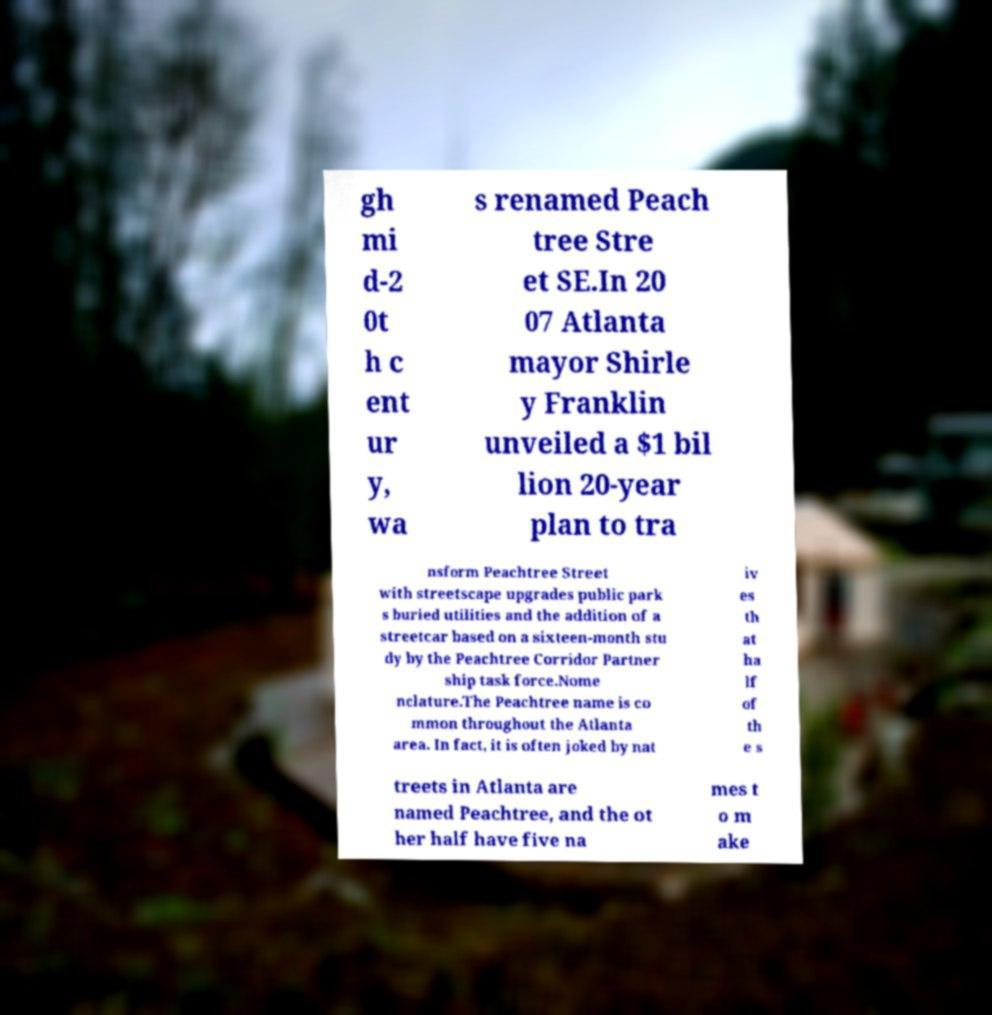Can you accurately transcribe the text from the provided image for me? gh mi d-2 0t h c ent ur y, wa s renamed Peach tree Stre et SE.In 20 07 Atlanta mayor Shirle y Franklin unveiled a $1 bil lion 20-year plan to tra nsform Peachtree Street with streetscape upgrades public park s buried utilities and the addition of a streetcar based on a sixteen-month stu dy by the Peachtree Corridor Partner ship task force.Nome nclature.The Peachtree name is co mmon throughout the Atlanta area. In fact, it is often joked by nat iv es th at ha lf of th e s treets in Atlanta are named Peachtree, and the ot her half have five na mes t o m ake 